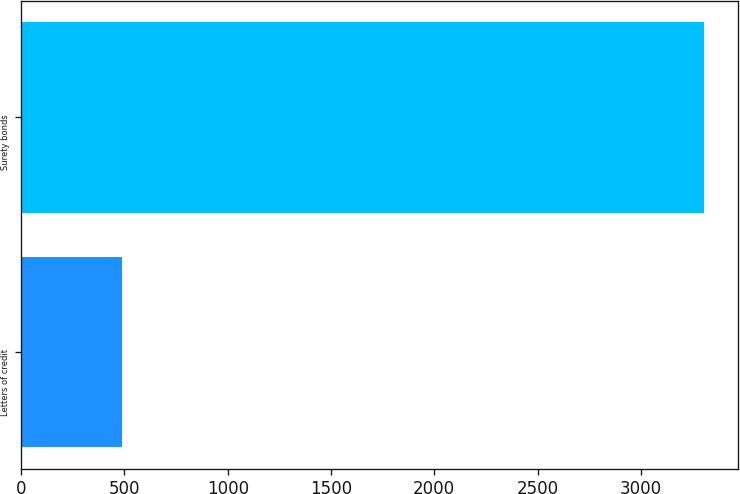Convert chart. <chart><loc_0><loc_0><loc_500><loc_500><bar_chart><fcel>Letters of credit<fcel>Surety bonds<nl><fcel>490.3<fcel>3307.3<nl></chart> 